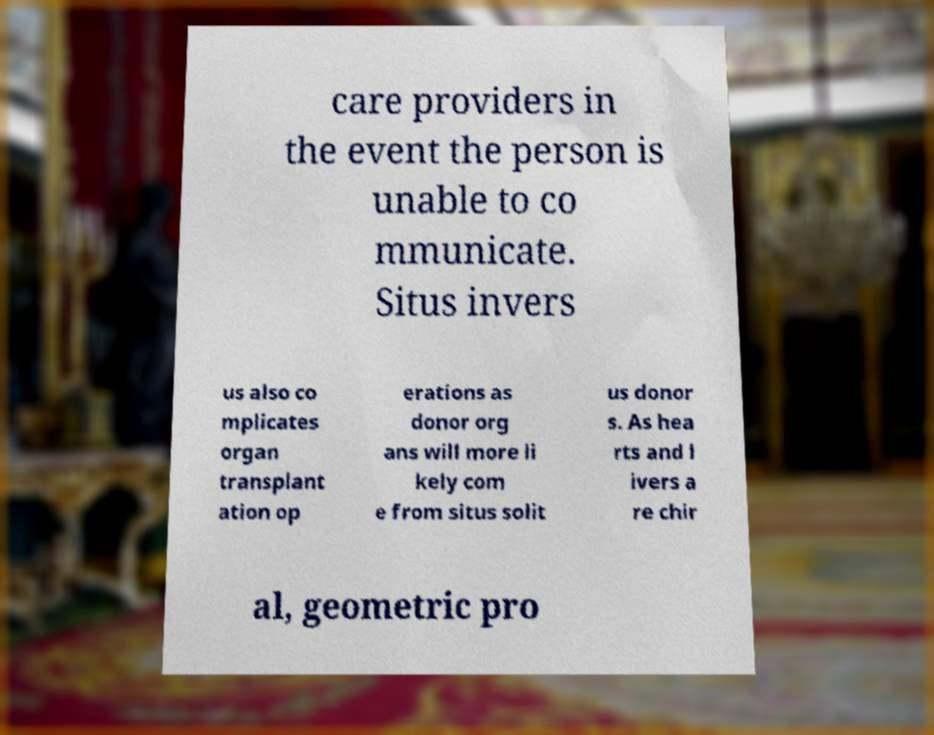Could you assist in decoding the text presented in this image and type it out clearly? care providers in the event the person is unable to co mmunicate. Situs invers us also co mplicates organ transplant ation op erations as donor org ans will more li kely com e from situs solit us donor s. As hea rts and l ivers a re chir al, geometric pro 